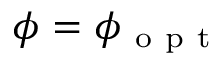<formula> <loc_0><loc_0><loc_500><loc_500>\phi = \phi _ { o p t }</formula> 